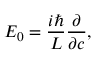<formula> <loc_0><loc_0><loc_500><loc_500>E _ { 0 } = { \frac { i } { L } } { \frac { \partial } { \partial c } } ,</formula> 